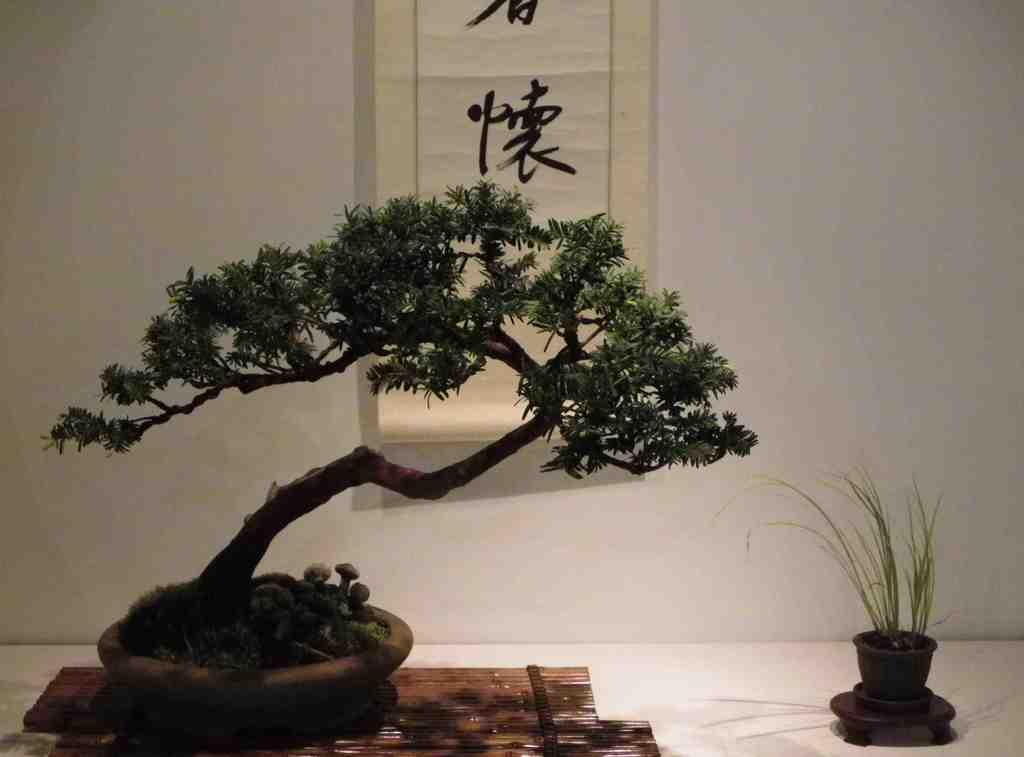What type of pots are present in the image? There is a plant pot and a grass pot in the image. What can be seen on the floor in the image? The floor is visible in the image. What is on the wall in the image? The wall is visible in the image, and there is a poster on it. Can you describe the background of the image? The background of the image includes the wall and the floor. What type of metal is the man wearing in the image? There is no man present in the image, so it is not possible to determine what type of metal he might be wearing. 